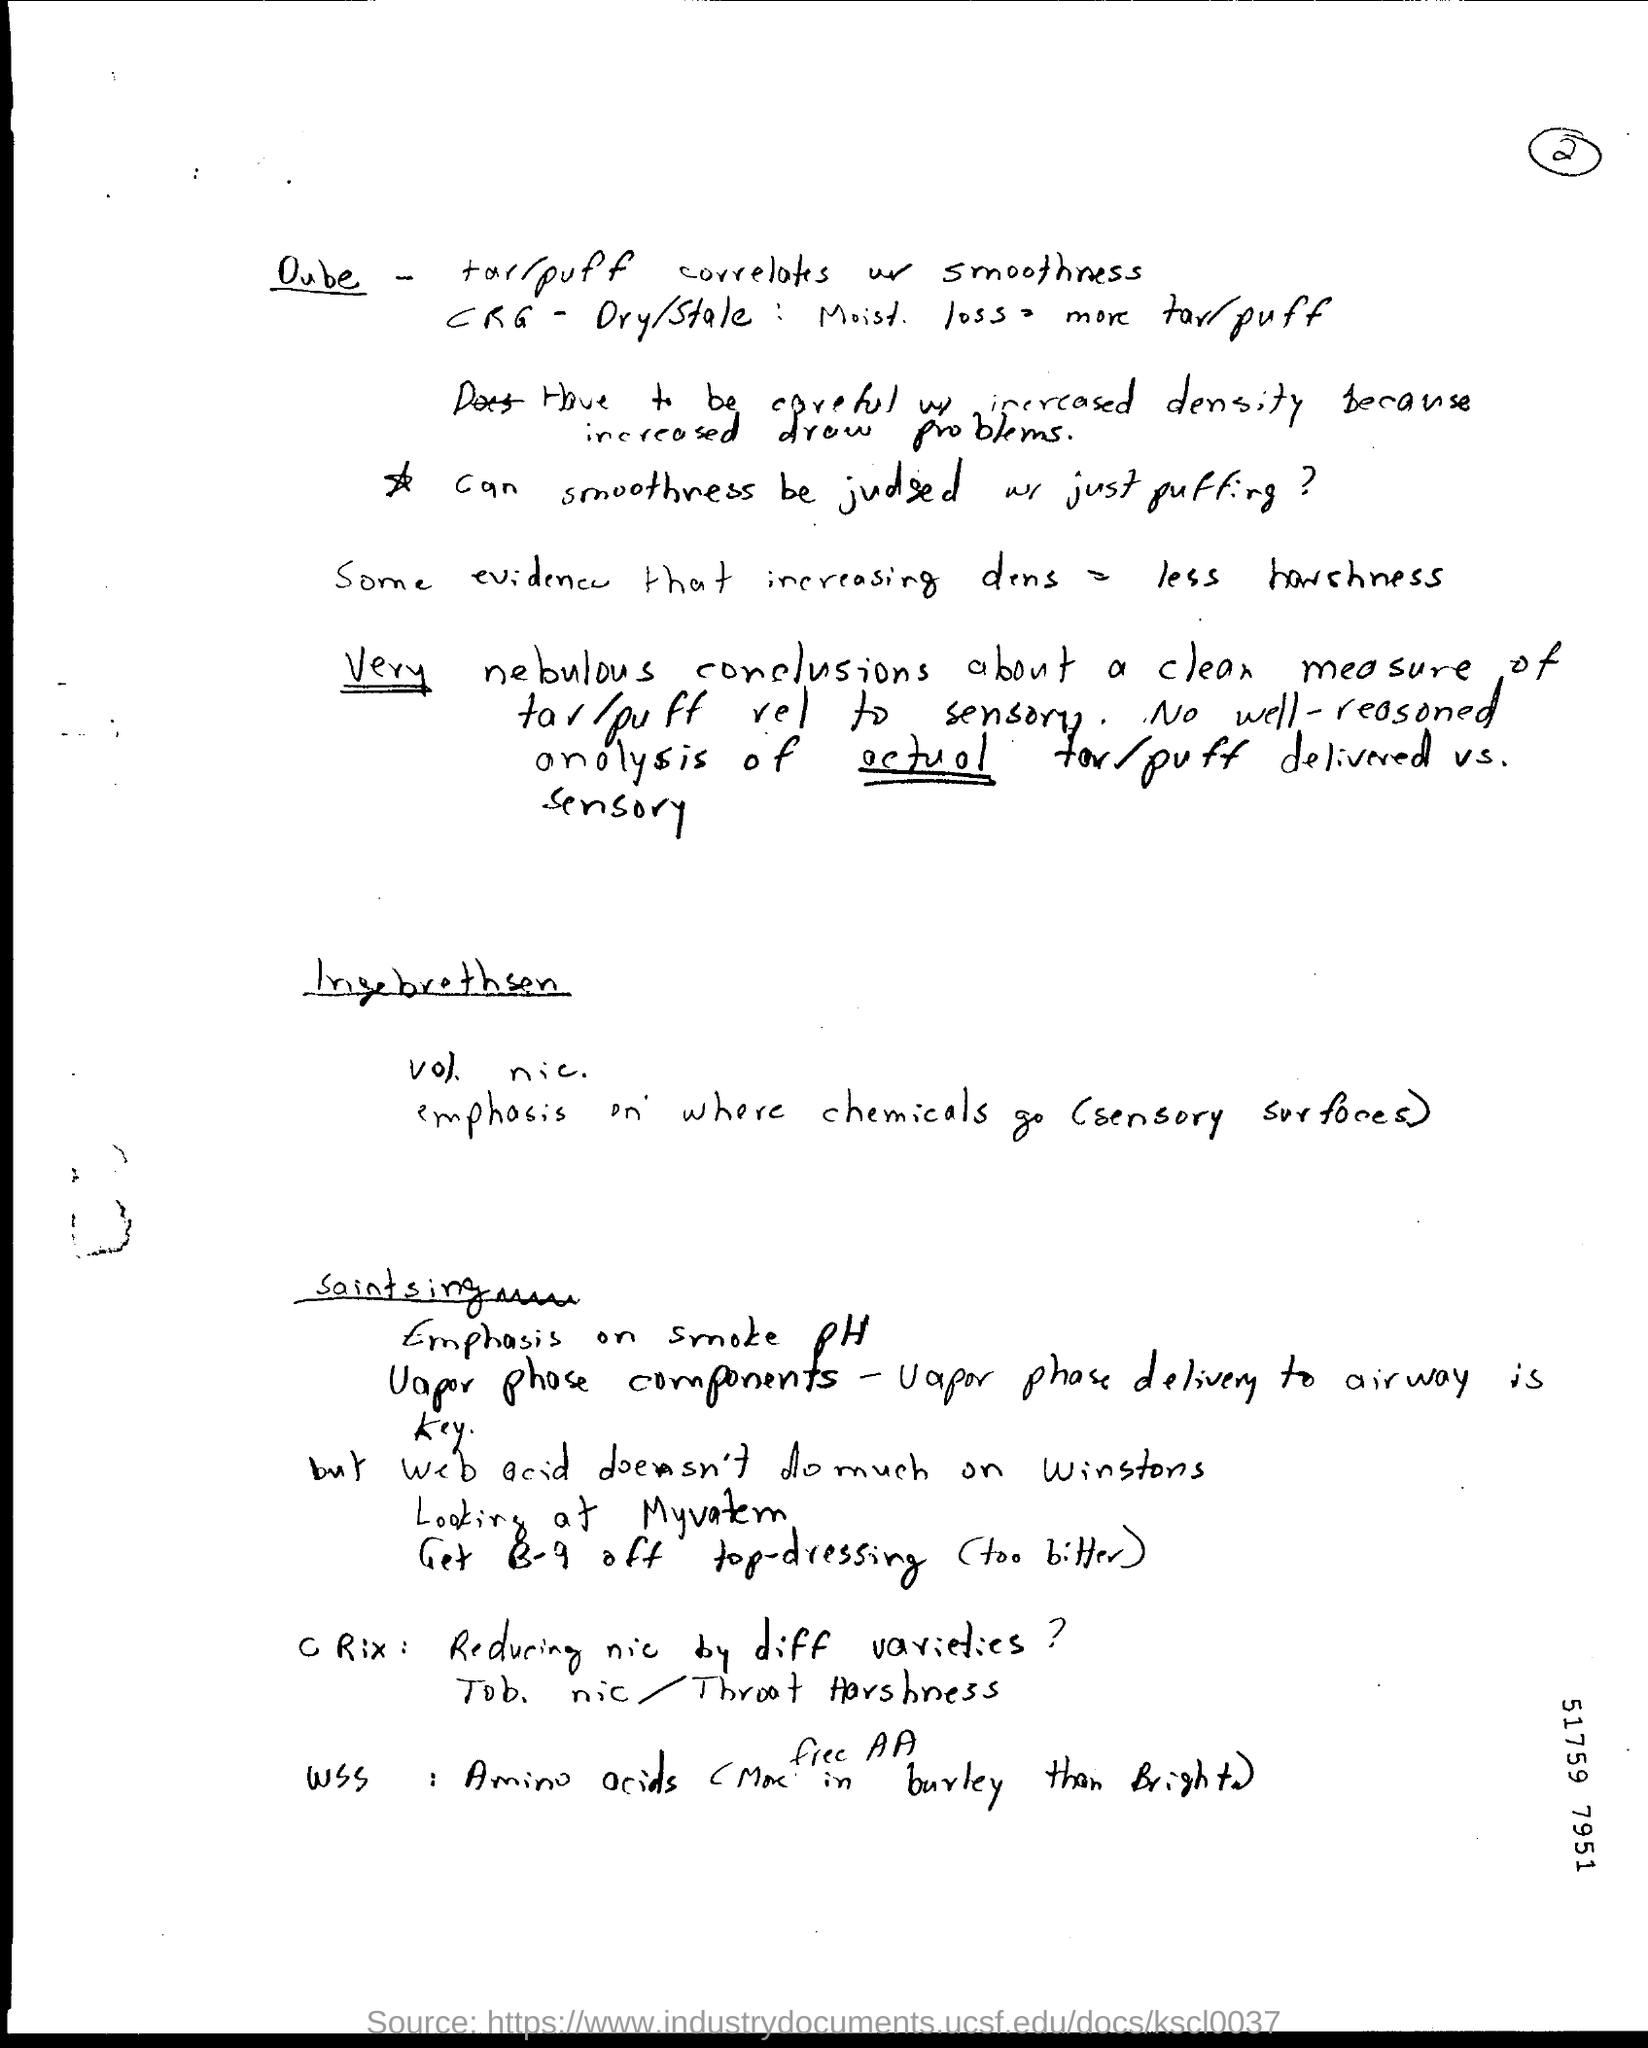Draw attention to some important aspects in this diagram. The number indicated on the bottom right side of the document is 51759, and the last four digits are 7951. What is the page number mentioned in this document?" the speaker asked, pointing to it with their finger. "2...," they continued, trailing off with a slight emphasis on the number. 